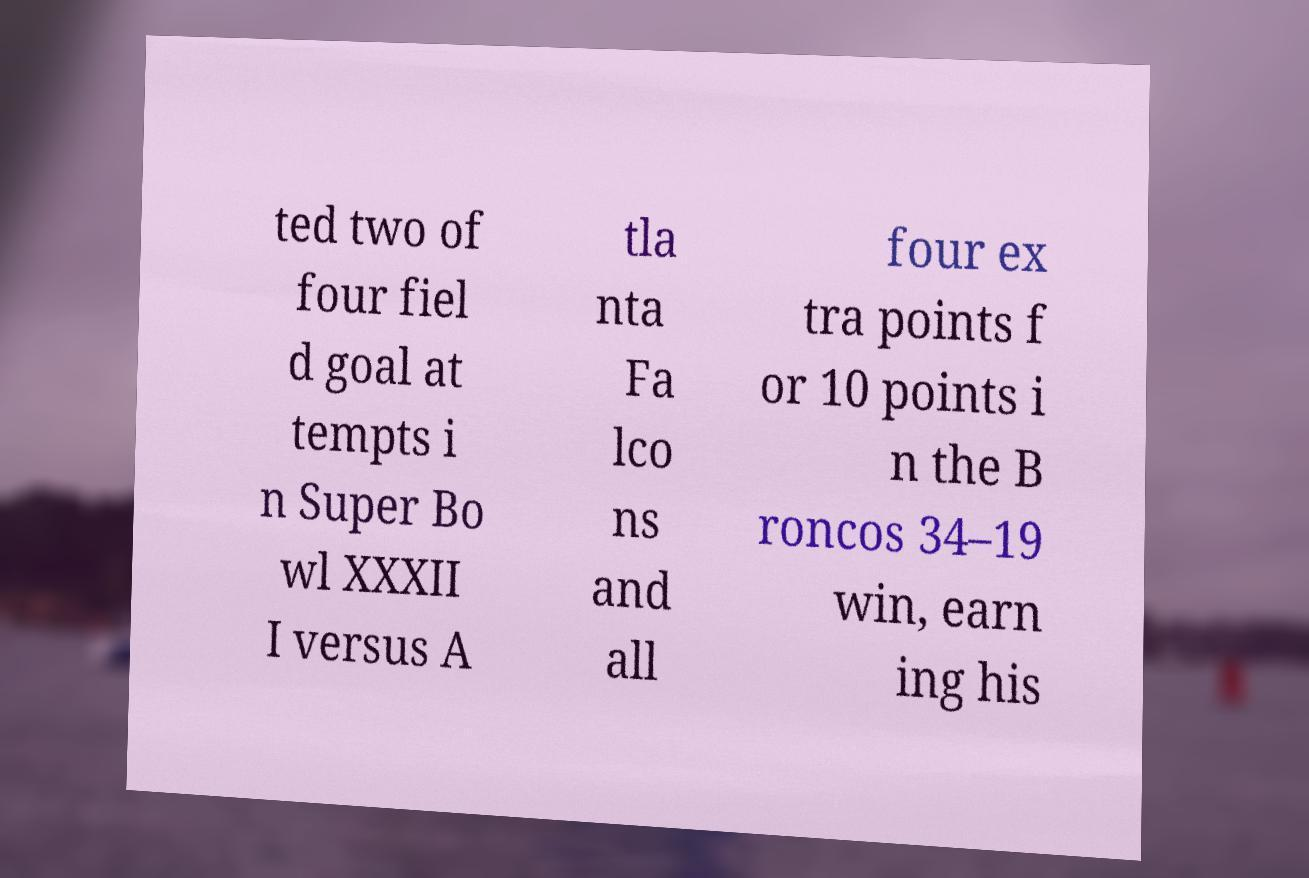Can you read and provide the text displayed in the image?This photo seems to have some interesting text. Can you extract and type it out for me? ted two of four fiel d goal at tempts i n Super Bo wl XXXII I versus A tla nta Fa lco ns and all four ex tra points f or 10 points i n the B roncos 34–19 win, earn ing his 